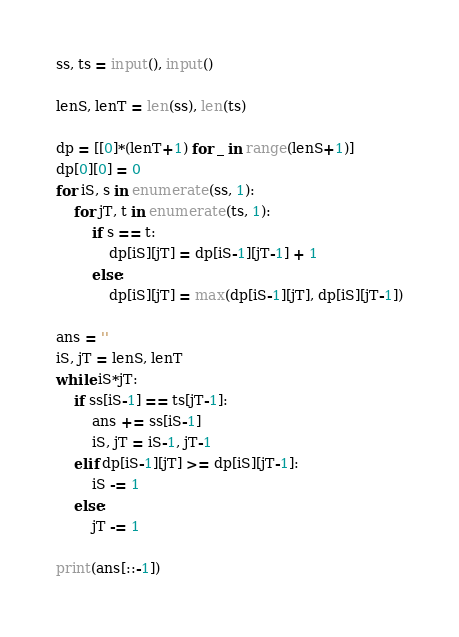Convert code to text. <code><loc_0><loc_0><loc_500><loc_500><_Python_>ss, ts = input(), input()

lenS, lenT = len(ss), len(ts)

dp = [[0]*(lenT+1) for _ in range(lenS+1)]
dp[0][0] = 0
for iS, s in enumerate(ss, 1):
    for jT, t in enumerate(ts, 1):
        if s == t:
            dp[iS][jT] = dp[iS-1][jT-1] + 1
        else:
            dp[iS][jT] = max(dp[iS-1][jT], dp[iS][jT-1])

ans = ''
iS, jT = lenS, lenT
while iS*jT:
    if ss[iS-1] == ts[jT-1]:
        ans += ss[iS-1]
        iS, jT = iS-1, jT-1
    elif dp[iS-1][jT] >= dp[iS][jT-1]:
        iS -= 1
    else:
        jT -= 1

print(ans[::-1])
</code> 